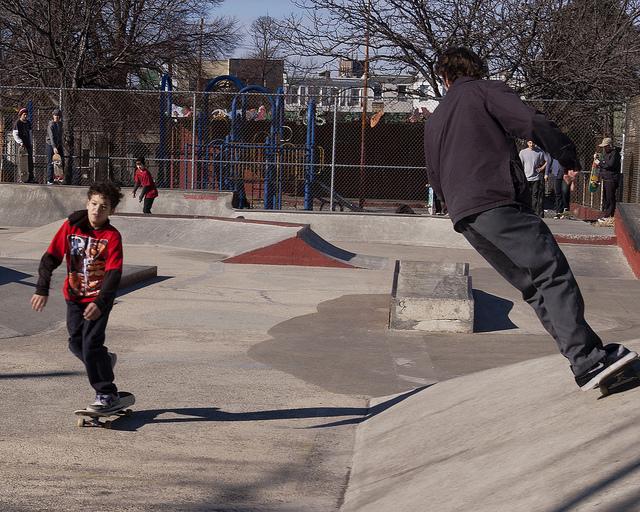Should the little girl wear boots in this weather?
Give a very brief answer. No. Why is the sky clear if it's so cold?
Be succinct. Winter. Is this an appropriate place for this sport?
Give a very brief answer. Yes. What medium is the park decorated with?
Concise answer only. Concrete. Are they riding the same vehicle?
Write a very short answer. No. Is the man wearing protective gear?
Concise answer only. No. How many people are shown?
Answer briefly. 8. Do the men have sun in their eyes?
Answer briefly. No. Is this a gladiator fight to the death?
Give a very brief answer. No. What is the wall made of?
Keep it brief. Concrete. Is the horizon tilted in the image?
Concise answer only. No. Who appears to be the better skateboarder?
Short answer required. Right. Are they going skiing?
Concise answer only. No. What is behind the fence?
Keep it brief. Playground. Is he wearing a red sweatshirt?
Quick response, please. Yes. How many children are wearing red coats?
Answer briefly. 2. 